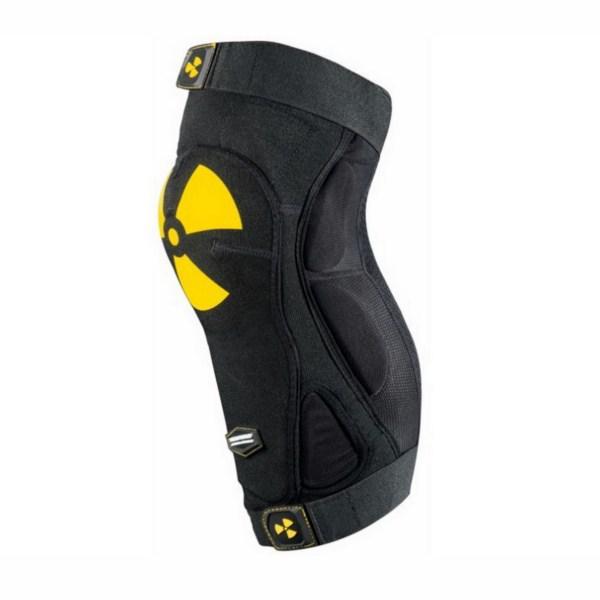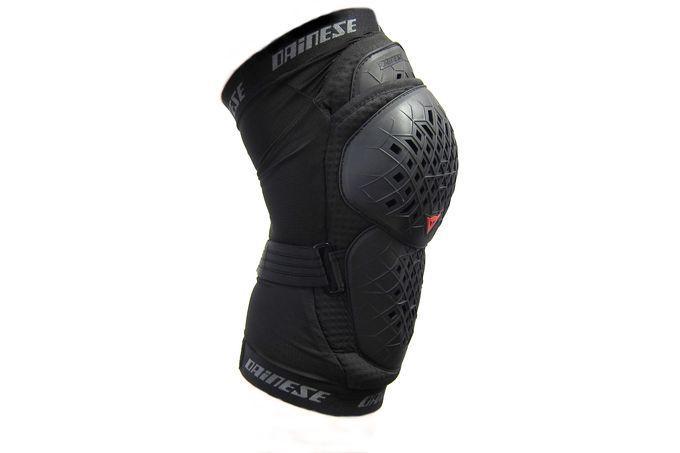The first image is the image on the left, the second image is the image on the right. Examine the images to the left and right. Is the description "One image shows what the back side of the knee pad looks like." accurate? Answer yes or no. No. The first image is the image on the left, the second image is the image on the right. Evaluate the accuracy of this statement regarding the images: "All of the images contain only one knee guard.". Is it true? Answer yes or no. Yes. 